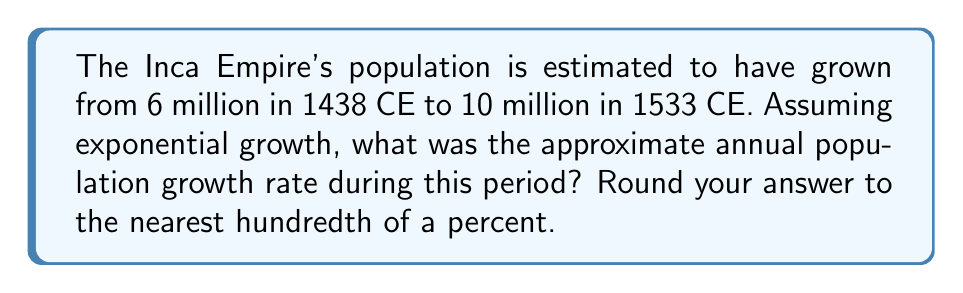Show me your answer to this math problem. To solve this problem, we'll use the exponential growth formula:

$$ P(t) = P_0 \cdot e^{rt} $$

Where:
$P(t)$ is the final population
$P_0$ is the initial population
$r$ is the annual growth rate
$t$ is the time in years

1. We know:
   $P_0 = 6$ million
   $P(t) = 10$ million
   $t = 1533 - 1438 = 95$ years

2. Plug these values into the formula:
   $$ 10 = 6 \cdot e^{95r} $$

3. Divide both sides by 6:
   $$ \frac{10}{6} = e^{95r} $$

4. Take the natural logarithm of both sides:
   $$ \ln(\frac{10}{6}) = 95r $$

5. Solve for $r$:
   $$ r = \frac{\ln(\frac{10}{6})}{95} $$

6. Calculate the value:
   $$ r = \frac{\ln(1.6667)}{95} \approx 0.005418 $$

7. Convert to a percentage:
   $$ 0.005418 \cdot 100\% \approx 0.5418\% $$

8. Round to the nearest hundredth:
   $$ 0.54\% $$
Answer: 0.54% 